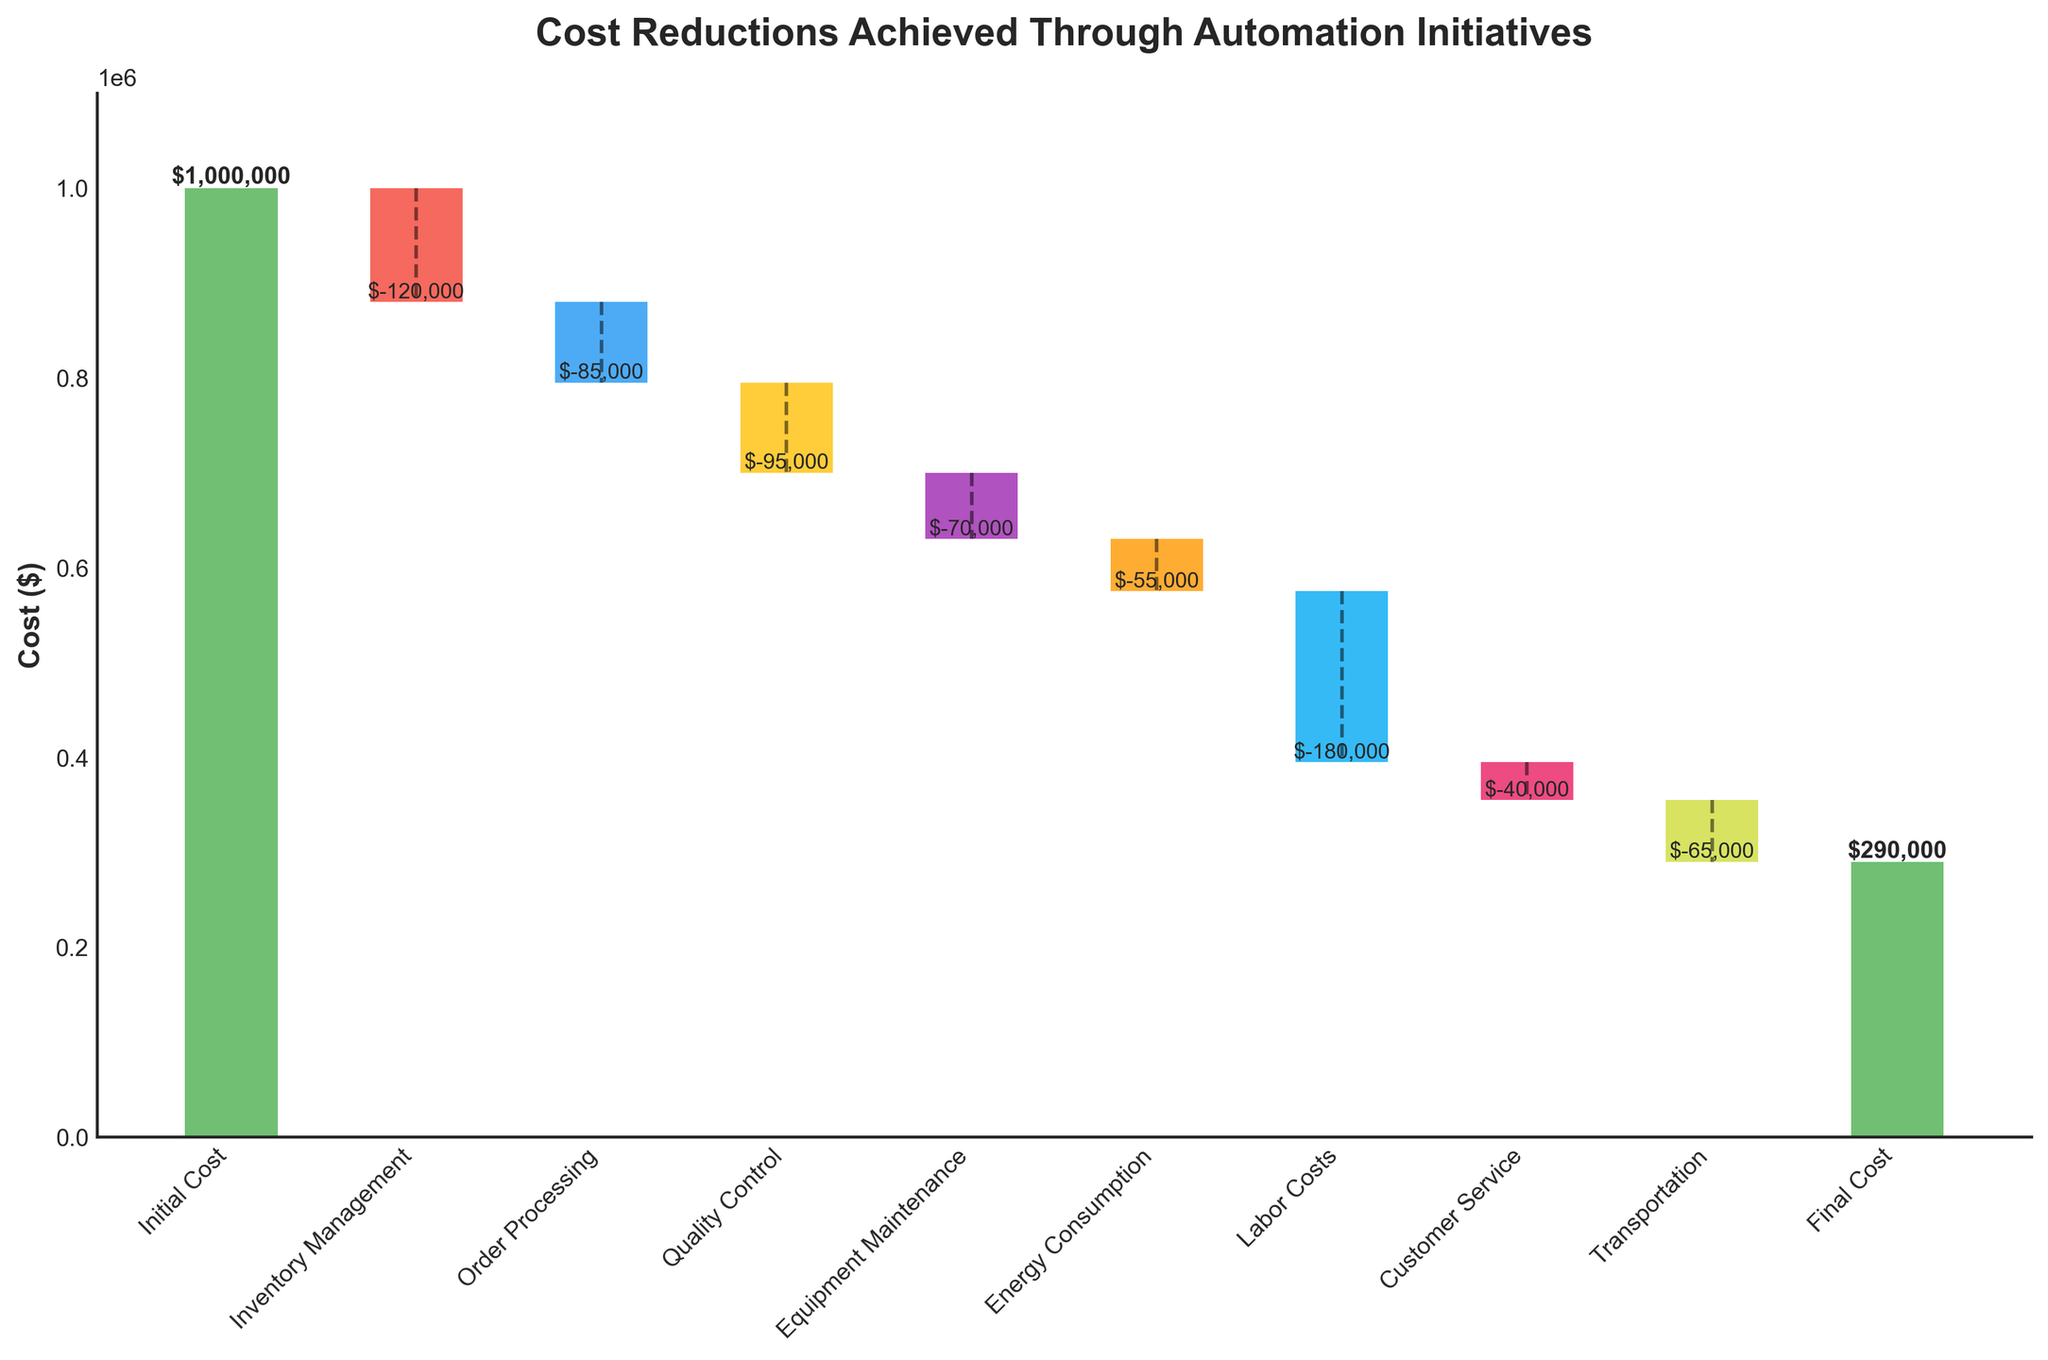What's the title of the chart? The title of the chart is prominently displayed at the top.
Answer: Cost Reductions Achieved Through Automation Initiatives What are the labels on the x-axis and y-axis? The x-axis and y-axis are labeled to help interpret the data in the chart.
Answer: Steps (x-axis) and Cost ($) (y-axis) How much did inventory management save for the company? Inventory Management is one of the negative bars in the waterfall chart. The value is displayed either directly on the chart or can be inferred from the axis.
Answer: $120,000 Which step contributed the most to cost reduction? By comparing the height of the negative bars in the waterfall chart, we can identify the step with the highest magnitude.
Answer: Labor Costs What is the final cost after all the reductions? The final cost is represented by the last bar on the waterfall chart.
Answer: $290,000 How much total cost reduction did the automation initiatives achieve? Add all the individual cost reduction values together, which are represented by the negative bars, and summarize the result.
Answer: $710,000 What is the difference in cost reduction between Labor Costs and Order Processing? Subtract the cost reduction amount of Order Processing from the Labor Costs.
Answer: $95,000 How many steps are involved in the automation initiative? Count the number of bars, including both positive and negative bars, on the waterfall chart.
Answer: 9 Which steps resulted in a cost increase or decrease? Identify the steps that resulted in either an increase or decrease in cost based on the direction of the bars.
Answer: Increase: Initial Cost, Final Cost; Decrease: Inventory Management, Order Processing, Quality Control, Equipment Maintenance, Energy Consumption, Labor Costs, Customer Service, Transportation What percentage of the total initial cost was saved through automation? Calculate the percentage by dividing the total cost reduction ($710,000) by the initial cost ($1,000,000) and multiplying by 100.
Answer: 71% 